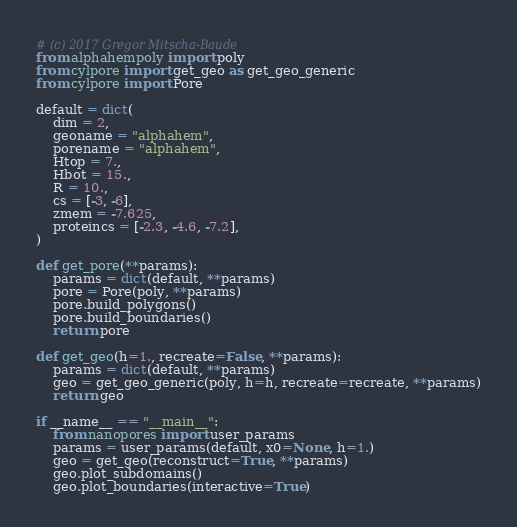<code> <loc_0><loc_0><loc_500><loc_500><_Python_># (c) 2017 Gregor Mitscha-Baude
from alphahempoly import poly
from cylpore import get_geo as get_geo_generic
from cylpore import Pore

default = dict(
    dim = 2,
    geoname = "alphahem",
    porename = "alphahem",
    Htop = 7.,
    Hbot = 15.,
    R = 10.,
    cs = [-3, -6],
    zmem = -7.625,
    proteincs = [-2.3, -4.6, -7.2],
)

def get_pore(**params):
    params = dict(default, **params)
    pore = Pore(poly, **params)
    pore.build_polygons()
    pore.build_boundaries()
    return pore

def get_geo(h=1., recreate=False, **params):
    params = dict(default, **params)
    geo = get_geo_generic(poly, h=h, recreate=recreate, **params)
    return geo

if __name__ == "__main__":
    from nanopores import user_params
    params = user_params(default, x0=None, h=1.)
    geo = get_geo(reconstruct=True, **params)
    geo.plot_subdomains()
    geo.plot_boundaries(interactive=True)
</code> 